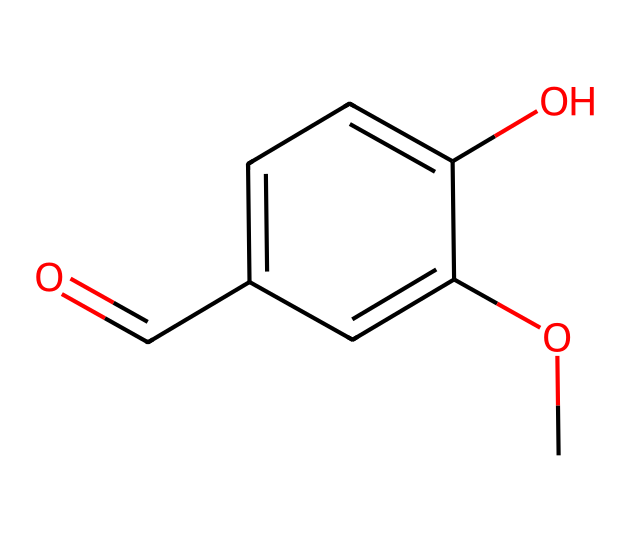What is the molecular formula of vanillin? To determine the molecular formula, count the number of each type of atom represented in the SMILES notation: there are 8 carbon (C) atoms, 8 hydrogen (H) atoms, and 3 oxygen (O) atoms. Thus, the molecular formula is C8H8O3.
Answer: C8H8O3 How many carbon atoms are in vanillin? By examining the SMILES notation, the 'c' and 'C' characters denote carbon atoms. Counting them reveals there are 8 carbon atoms in total.
Answer: 8 What is the functional group present in vanillin? In the provided structure, the presence of the carbonyl group (C=O) indicates a ketone or aldehyde functional group. Here, vanillin specifically contains an aldehyde functional group due to the terminal carbonyl.
Answer: aldehyde What is the significance of the methoxy group in vanillin? The methoxy group (–OCH3) contributes to the sweet aroma and flavor profile of vanillin, enhancing its overall properties as a flavoring agent in food and fragrance industries.
Answer: aroma Which part of the molecule is responsible for its flavor? The aromatic ring structure, particularly influenced by the methoxy and hydroxy groups bonded to it, gives vanillin its characteristic flavor profile. The interaction of these substituents contributes to its sweet, vanilla flavor.
Answer: aromatic ring How many oxygen atoms are present in the structure of vanillin? In the molecular formula derived from the SMILES notation, the presence of the 'O' character indicates oxygen atoms. By counting the occurrences in the formula, it is clear that vanillin contains 3 oxygen atoms.
Answer: 3 